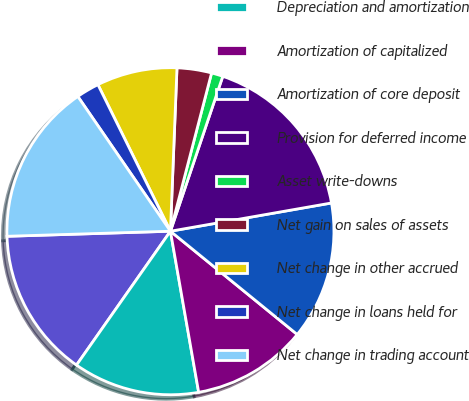<chart> <loc_0><loc_0><loc_500><loc_500><pie_chart><fcel>Provision for credit losses<fcel>Depreciation and amortization<fcel>Amortization of capitalized<fcel>Amortization of core deposit<fcel>Provision for deferred income<fcel>Asset write-downs<fcel>Net gain on sales of assets<fcel>Net change in other accrued<fcel>Net change in loans held for<fcel>Net change in trading account<nl><fcel>14.77%<fcel>12.5%<fcel>11.36%<fcel>13.64%<fcel>17.05%<fcel>1.14%<fcel>3.41%<fcel>7.95%<fcel>2.27%<fcel>15.91%<nl></chart> 